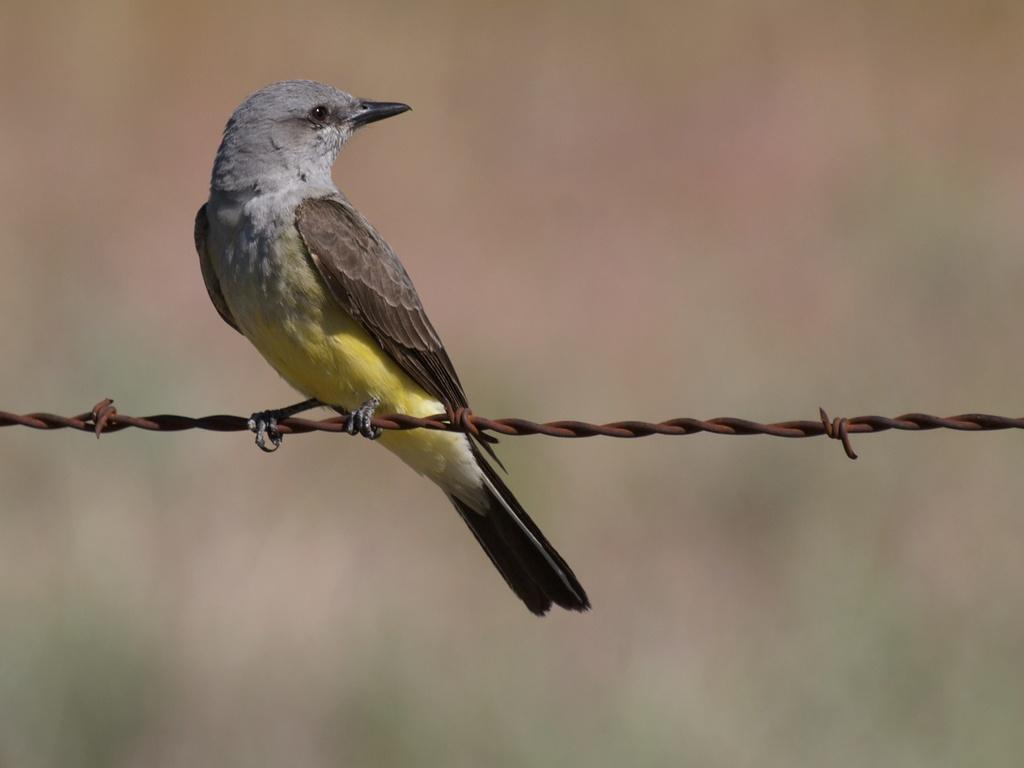What type of animal is in the image? There is a bird in the image. What colors can be seen on the bird? The bird has grey, brown, and yellow colors. Where is the bird located in the image? The bird is on an iron wire. What can be observed about the background of the image? The background of the image is blurred. How many daughters can be seen in the image? There are no daughters present in the image; it features a bird on an iron wire. What type of snails are crawling on the bird in the image? There are no snails present in the image; it features a bird on an iron wire. 